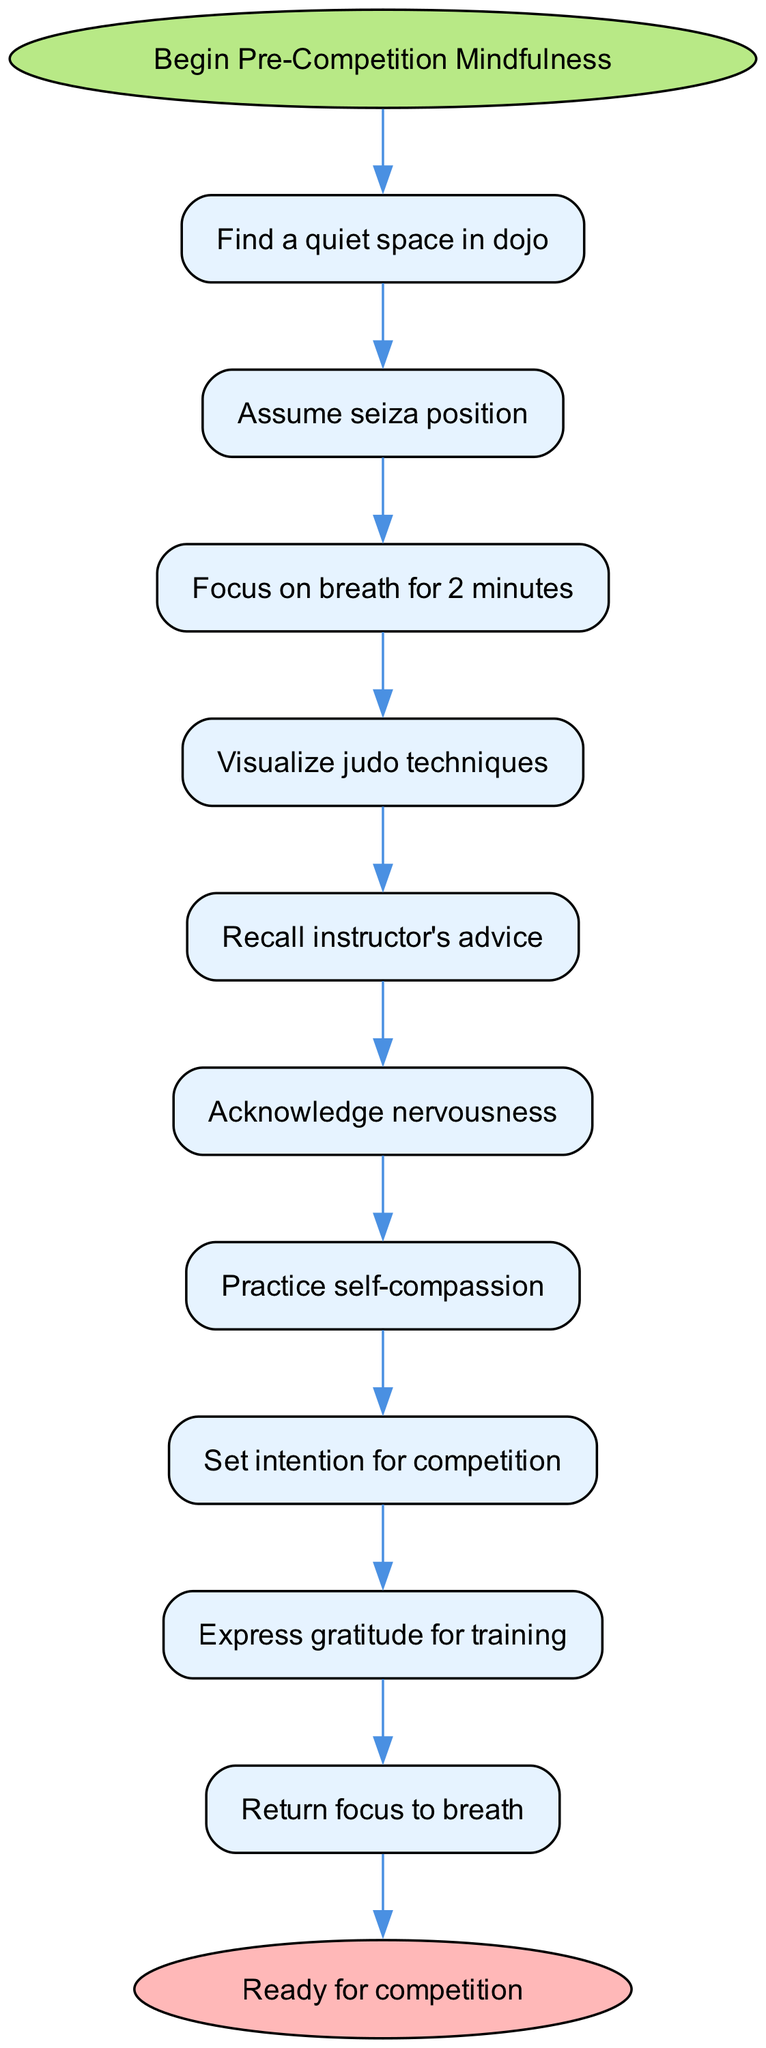What is the first step in the mindfulness meditation flow chart? The first step listed in the flow chart is "Find a quiet space in dojo." It is the initial action that starts the process.
Answer: Find a quiet space in dojo How many steps are there in total from start to end? The diagram indicates there are 10 steps in total, including the start and end nodes. Each of the flow elements constitutes a step.
Answer: 10 What is the last action before reaching the end node? The last action before reaching the end node is "Return focus to breath." This is the final task in the meditation sequence.
Answer: Return focus to breath Which step involves visualizing judo techniques? The step that involves visualizing judo techniques is labeled "Visualize judo techniques." It is the fourth step in the flow.
Answer: Visualize judo techniques What is the significance of acknowledging nervousness? Acknowledging nervousness is significant as it is the sixth step that leads to practicing self-compassion, which helps in managing competition anxiety.
Answer: It leads to practicing self-compassion What happens after recalling the instructor's advice? After recalling the instructor's advice, the next step is to "Acknowledge nervousness," which indicates an emotional response and awareness influenced by the advice.
Answer: Acknowledge nervousness How does the flow chart suggest expressing gratitude? The flow chart suggests expressing gratitude as the ninth step, specifically "Express gratitude for training," which emphasizes appreciation for the preparation process.
Answer: Express gratitude for training What is the transition from step seven to step eight? The transition from step seven, “Practice self-compassion,” to step eight, “Set intention for competition,” signifies a shift from emotional awareness to focused motivation for competition.
Answer: Set intention for competition How does the diagram help prepare for competition? The diagram helps prepare for competition by outlining a structured meditation process that includes aspects like breathing, visualization, and mental focus, all aimed at readiness.
Answer: Structured meditation process 